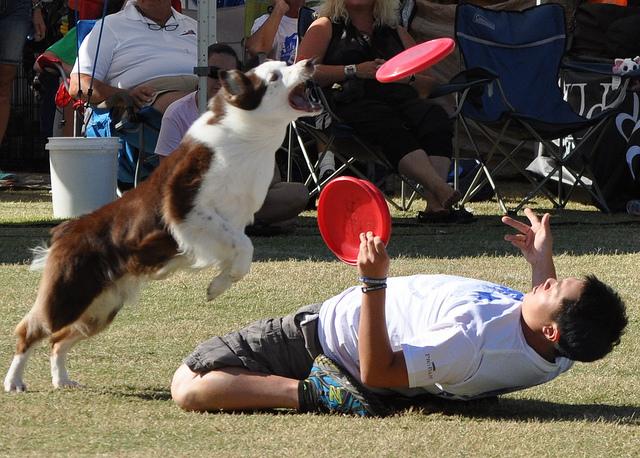What color are the disks?
Be succinct. Red. How many frisbees are there?
Give a very brief answer. 2. Did the man fall down?
Write a very short answer. No. 